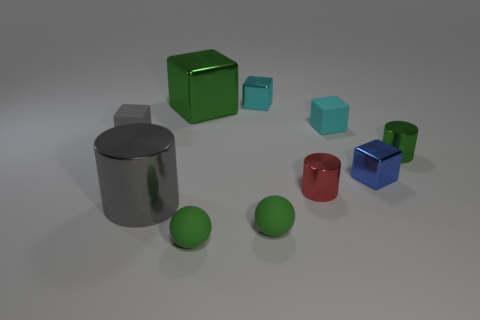Subtract all gray cubes. Subtract all red balls. How many cubes are left? 4 Subtract all spheres. How many objects are left? 8 Add 2 tiny gray objects. How many tiny gray objects are left? 3 Add 6 large metallic objects. How many large metallic objects exist? 8 Subtract 0 blue balls. How many objects are left? 10 Subtract all tiny gray things. Subtract all tiny green matte things. How many objects are left? 7 